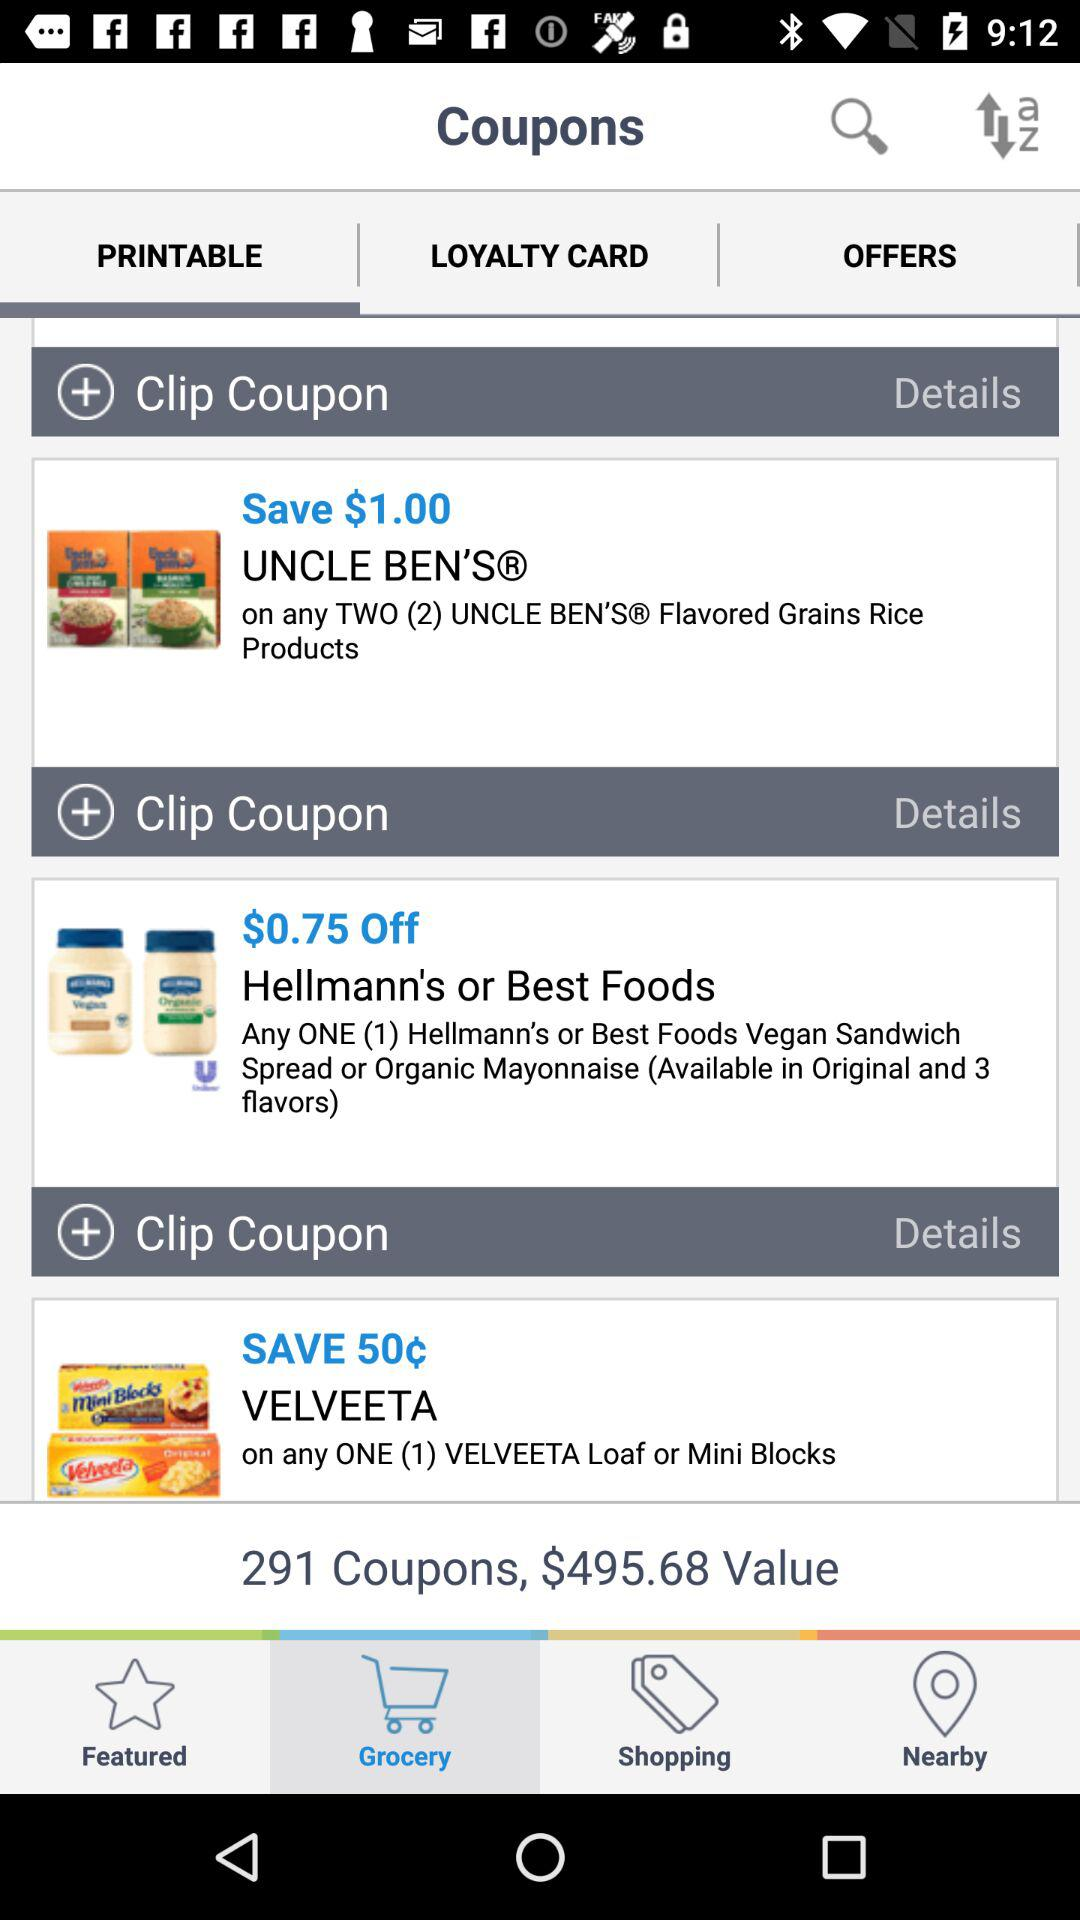What is the value of two hundred ninety-one coupons? The value is $495.68. 